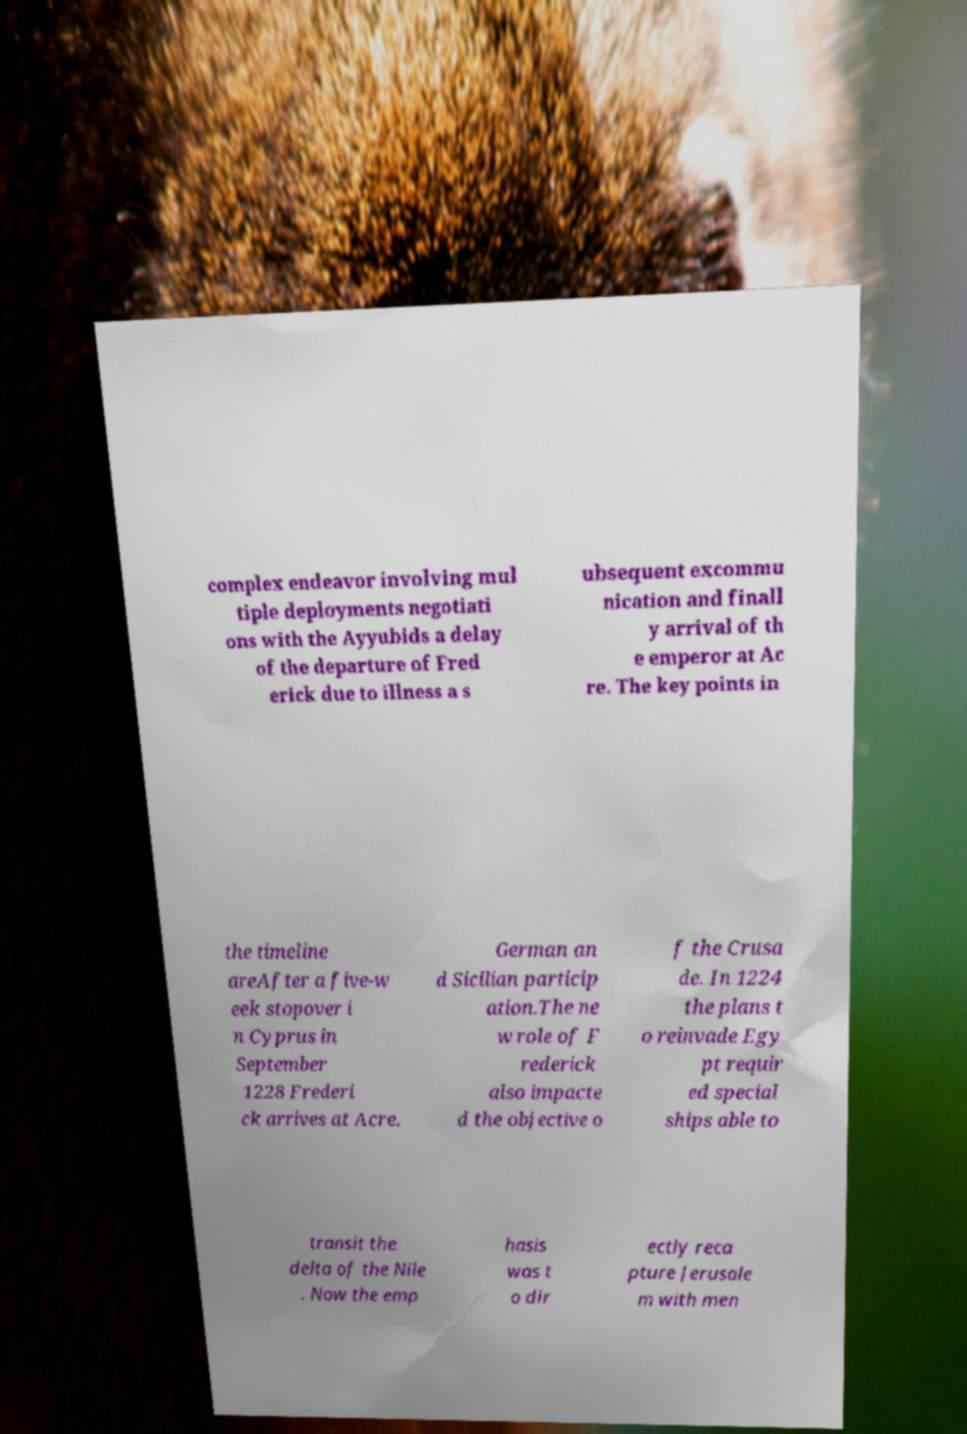For documentation purposes, I need the text within this image transcribed. Could you provide that? complex endeavor involving mul tiple deployments negotiati ons with the Ayyubids a delay of the departure of Fred erick due to illness a s ubsequent excommu nication and finall y arrival of th e emperor at Ac re. The key points in the timeline areAfter a five-w eek stopover i n Cyprus in September 1228 Frederi ck arrives at Acre. German an d Sicilian particip ation.The ne w role of F rederick also impacte d the objective o f the Crusa de. In 1224 the plans t o reinvade Egy pt requir ed special ships able to transit the delta of the Nile . Now the emp hasis was t o dir ectly reca pture Jerusale m with men 